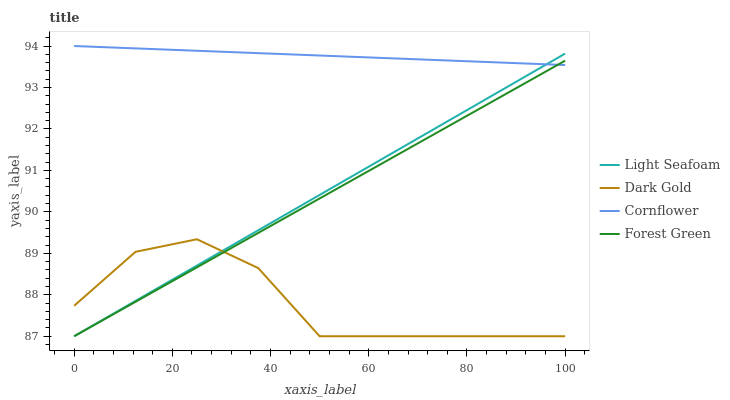Does Dark Gold have the minimum area under the curve?
Answer yes or no. Yes. Does Cornflower have the maximum area under the curve?
Answer yes or no. Yes. Does Forest Green have the minimum area under the curve?
Answer yes or no. No. Does Forest Green have the maximum area under the curve?
Answer yes or no. No. Is Forest Green the smoothest?
Answer yes or no. Yes. Is Dark Gold the roughest?
Answer yes or no. Yes. Is Light Seafoam the smoothest?
Answer yes or no. No. Is Light Seafoam the roughest?
Answer yes or no. No. Does Forest Green have the lowest value?
Answer yes or no. Yes. Does Cornflower have the highest value?
Answer yes or no. Yes. Does Forest Green have the highest value?
Answer yes or no. No. Is Dark Gold less than Cornflower?
Answer yes or no. Yes. Is Cornflower greater than Dark Gold?
Answer yes or no. Yes. Does Forest Green intersect Cornflower?
Answer yes or no. Yes. Is Forest Green less than Cornflower?
Answer yes or no. No. Is Forest Green greater than Cornflower?
Answer yes or no. No. Does Dark Gold intersect Cornflower?
Answer yes or no. No. 